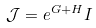Convert formula to latex. <formula><loc_0><loc_0><loc_500><loc_500>\mathcal { J } = e ^ { G + H } I</formula> 